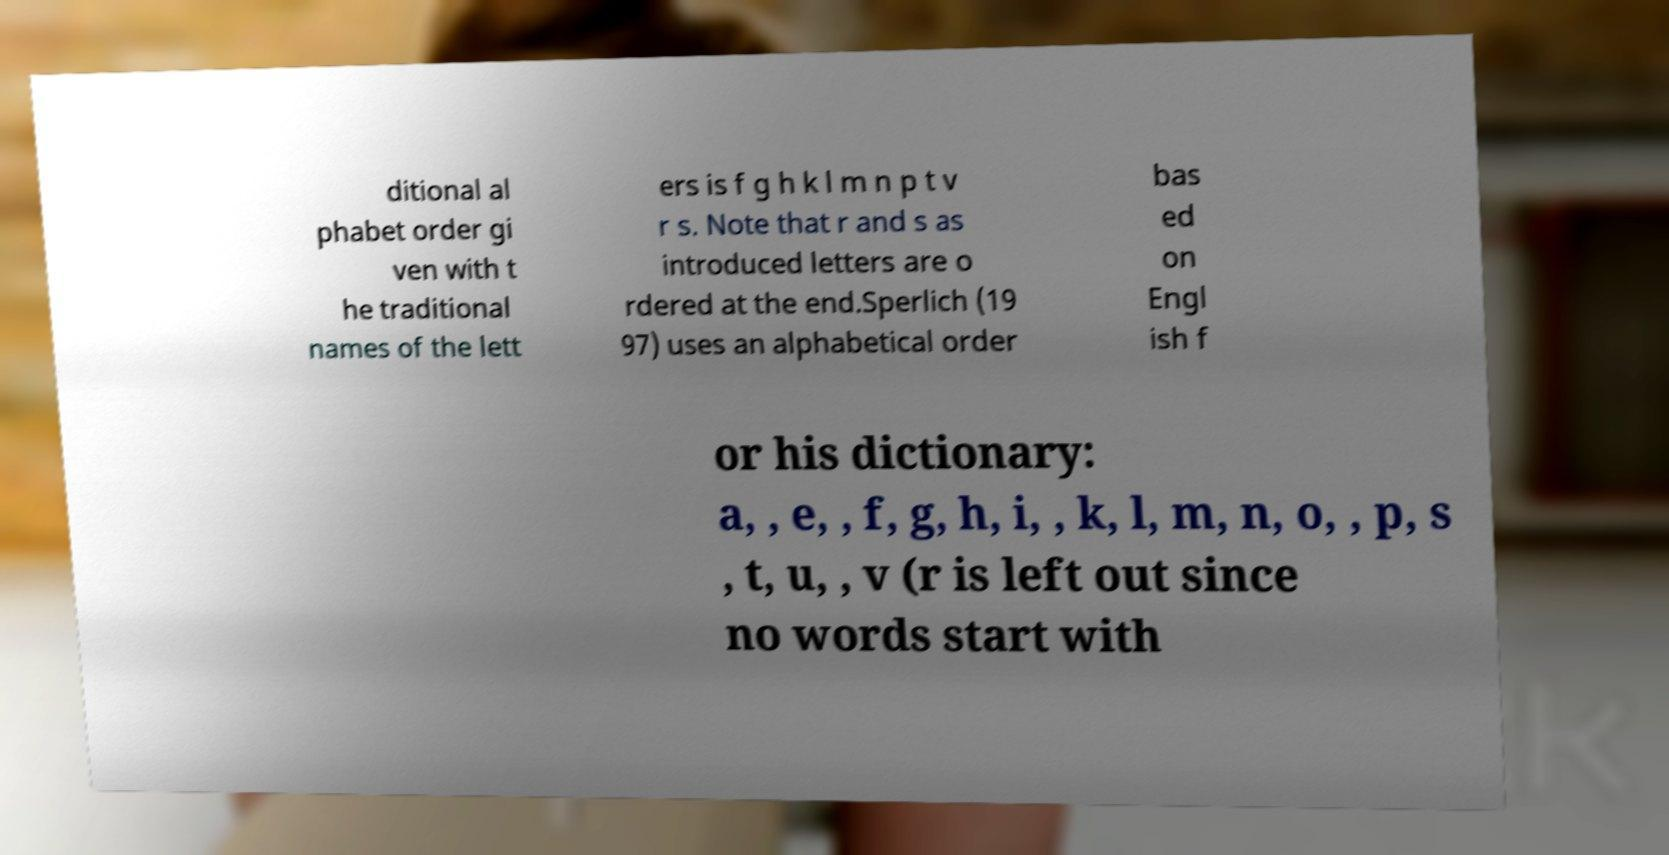What messages or text are displayed in this image? I need them in a readable, typed format. ditional al phabet order gi ven with t he traditional names of the lett ers is f g h k l m n p t v r s. Note that r and s as introduced letters are o rdered at the end.Sperlich (19 97) uses an alphabetical order bas ed on Engl ish f or his dictionary: a, , e, , f, g, h, i, , k, l, m, n, o, , p, s , t, u, , v (r is left out since no words start with 